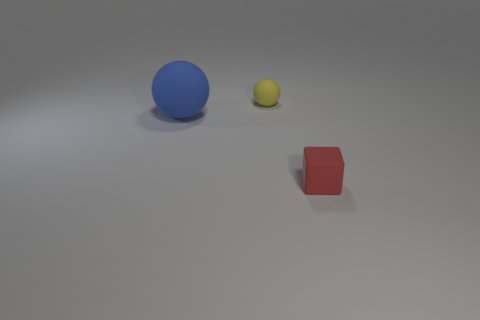Subtract 1 balls. How many balls are left? 1 Add 3 tiny red rubber things. How many objects exist? 6 Subtract all blocks. How many objects are left? 2 Subtract all red balls. Subtract all blue cylinders. How many balls are left? 2 Subtract all red cylinders. How many blue spheres are left? 1 Subtract all red blocks. Subtract all small rubber objects. How many objects are left? 0 Add 2 blue rubber objects. How many blue rubber objects are left? 3 Add 3 small red things. How many small red things exist? 4 Subtract all yellow spheres. How many spheres are left? 1 Subtract 0 brown blocks. How many objects are left? 3 